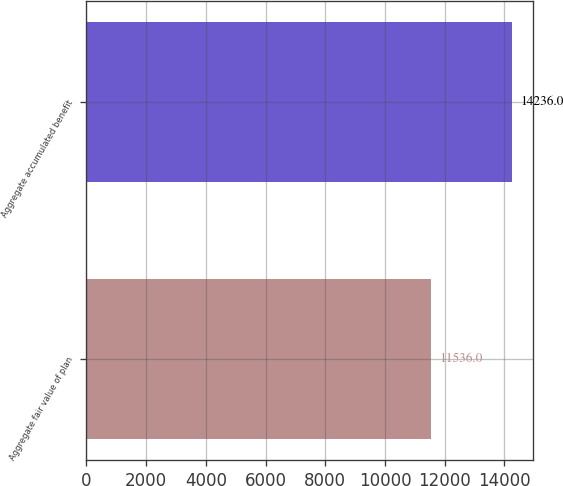Convert chart to OTSL. <chart><loc_0><loc_0><loc_500><loc_500><bar_chart><fcel>Aggregate fair value of plan<fcel>Aggregate accumulated benefit<nl><fcel>11536<fcel>14236<nl></chart> 